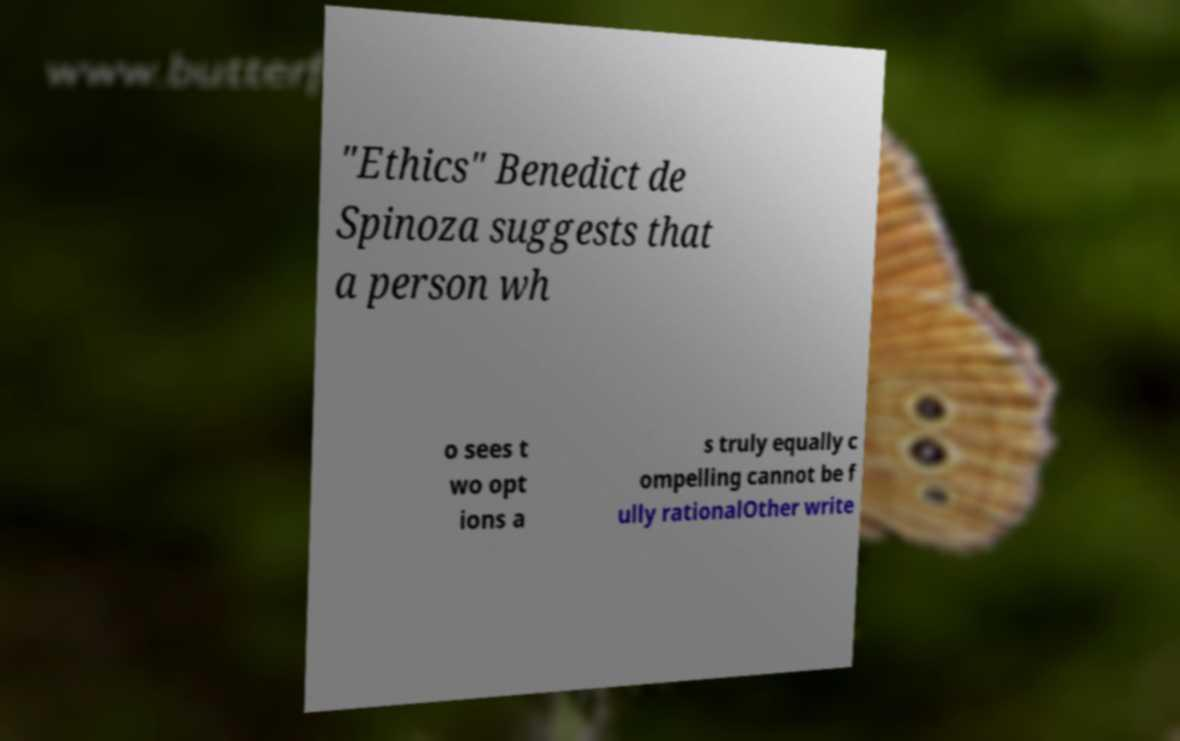Could you assist in decoding the text presented in this image and type it out clearly? "Ethics" Benedict de Spinoza suggests that a person wh o sees t wo opt ions a s truly equally c ompelling cannot be f ully rationalOther write 